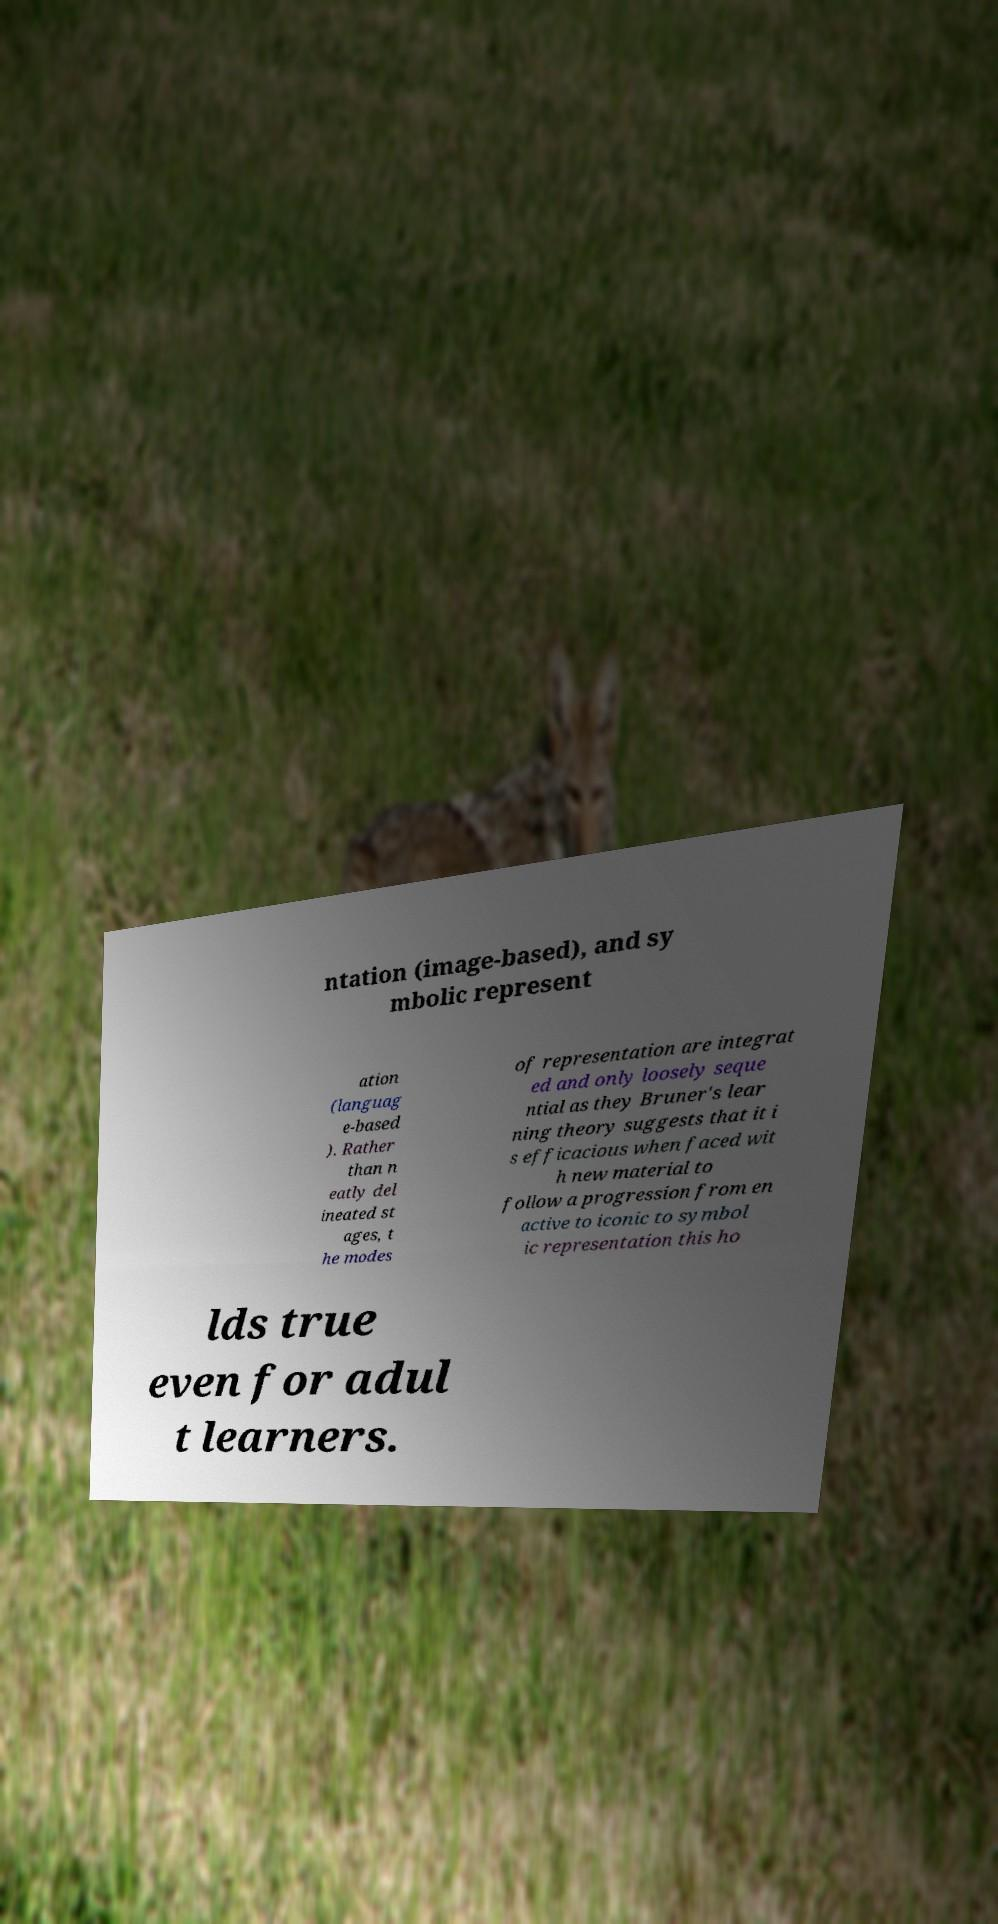Could you extract and type out the text from this image? ntation (image-based), and sy mbolic represent ation (languag e-based ). Rather than n eatly del ineated st ages, t he modes of representation are integrat ed and only loosely seque ntial as they Bruner's lear ning theory suggests that it i s efficacious when faced wit h new material to follow a progression from en active to iconic to symbol ic representation this ho lds true even for adul t learners. 